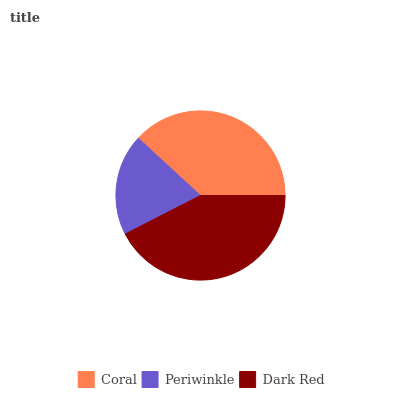Is Periwinkle the minimum?
Answer yes or no. Yes. Is Dark Red the maximum?
Answer yes or no. Yes. Is Dark Red the minimum?
Answer yes or no. No. Is Periwinkle the maximum?
Answer yes or no. No. Is Dark Red greater than Periwinkle?
Answer yes or no. Yes. Is Periwinkle less than Dark Red?
Answer yes or no. Yes. Is Periwinkle greater than Dark Red?
Answer yes or no. No. Is Dark Red less than Periwinkle?
Answer yes or no. No. Is Coral the high median?
Answer yes or no. Yes. Is Coral the low median?
Answer yes or no. Yes. Is Periwinkle the high median?
Answer yes or no. No. Is Dark Red the low median?
Answer yes or no. No. 